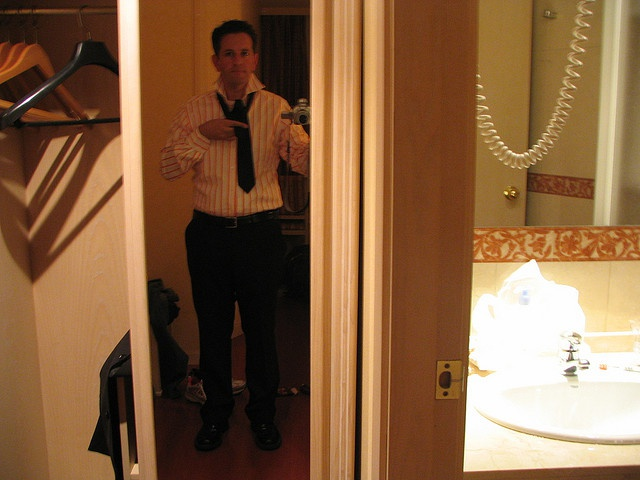Describe the objects in this image and their specific colors. I can see people in black, maroon, and brown tones, sink in black, white, and tan tones, suitcase in black tones, and tie in black, maroon, and brown tones in this image. 